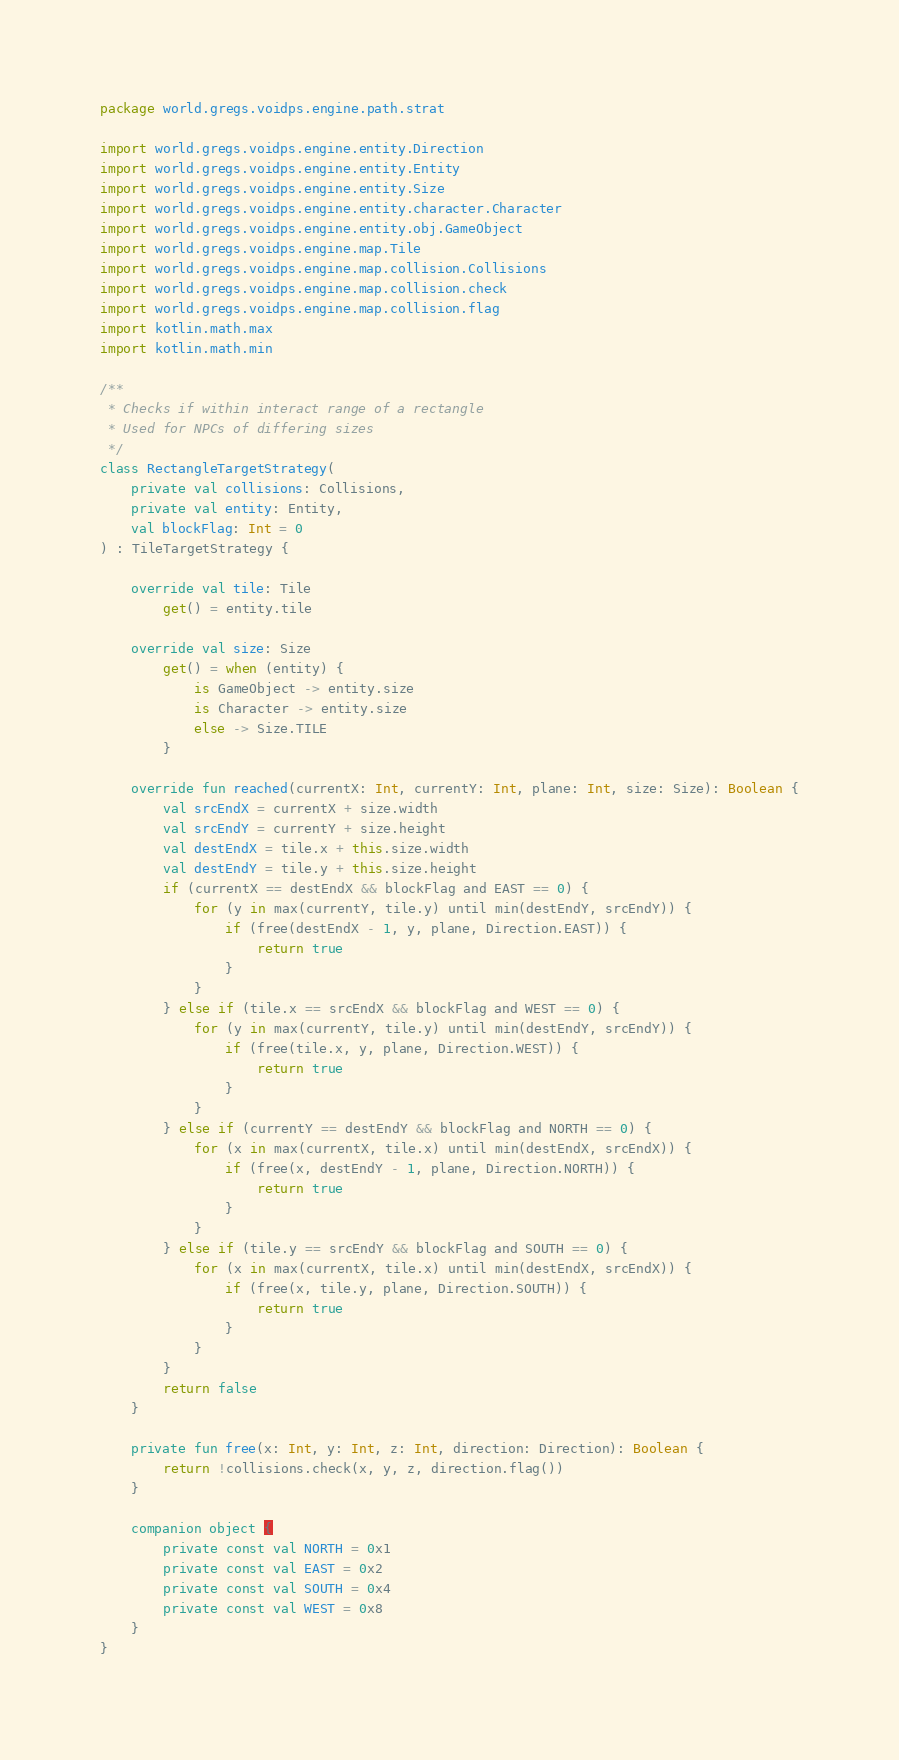Convert code to text. <code><loc_0><loc_0><loc_500><loc_500><_Kotlin_>package world.gregs.voidps.engine.path.strat

import world.gregs.voidps.engine.entity.Direction
import world.gregs.voidps.engine.entity.Entity
import world.gregs.voidps.engine.entity.Size
import world.gregs.voidps.engine.entity.character.Character
import world.gregs.voidps.engine.entity.obj.GameObject
import world.gregs.voidps.engine.map.Tile
import world.gregs.voidps.engine.map.collision.Collisions
import world.gregs.voidps.engine.map.collision.check
import world.gregs.voidps.engine.map.collision.flag
import kotlin.math.max
import kotlin.math.min

/**
 * Checks if within interact range of a rectangle
 * Used for NPCs of differing sizes
 */
class RectangleTargetStrategy(
    private val collisions: Collisions,
    private val entity: Entity,
    val blockFlag: Int = 0
) : TileTargetStrategy {

    override val tile: Tile
        get() = entity.tile

    override val size: Size
        get() = when (entity) {
            is GameObject -> entity.size
            is Character -> entity.size
            else -> Size.TILE
        }

    override fun reached(currentX: Int, currentY: Int, plane: Int, size: Size): Boolean {
        val srcEndX = currentX + size.width
        val srcEndY = currentY + size.height
        val destEndX = tile.x + this.size.width
        val destEndY = tile.y + this.size.height
        if (currentX == destEndX && blockFlag and EAST == 0) {
            for (y in max(currentY, tile.y) until min(destEndY, srcEndY)) {
                if (free(destEndX - 1, y, plane, Direction.EAST)) {
                    return true
                }
            }
        } else if (tile.x == srcEndX && blockFlag and WEST == 0) {
            for (y in max(currentY, tile.y) until min(destEndY, srcEndY)) {
                if (free(tile.x, y, plane, Direction.WEST)) {
                    return true
                }
            }
        } else if (currentY == destEndY && blockFlag and NORTH == 0) {
            for (x in max(currentX, tile.x) until min(destEndX, srcEndX)) {
                if (free(x, destEndY - 1, plane, Direction.NORTH)) {
                    return true
                }
            }
        } else if (tile.y == srcEndY && blockFlag and SOUTH == 0) {
            for (x in max(currentX, tile.x) until min(destEndX, srcEndX)) {
                if (free(x, tile.y, plane, Direction.SOUTH)) {
                    return true
                }
            }
        }
        return false
    }

    private fun free(x: Int, y: Int, z: Int, direction: Direction): Boolean {
        return !collisions.check(x, y, z, direction.flag())
    }

    companion object {
        private const val NORTH = 0x1
        private const val EAST = 0x2
        private const val SOUTH = 0x4
        private const val WEST = 0x8
    }
}</code> 